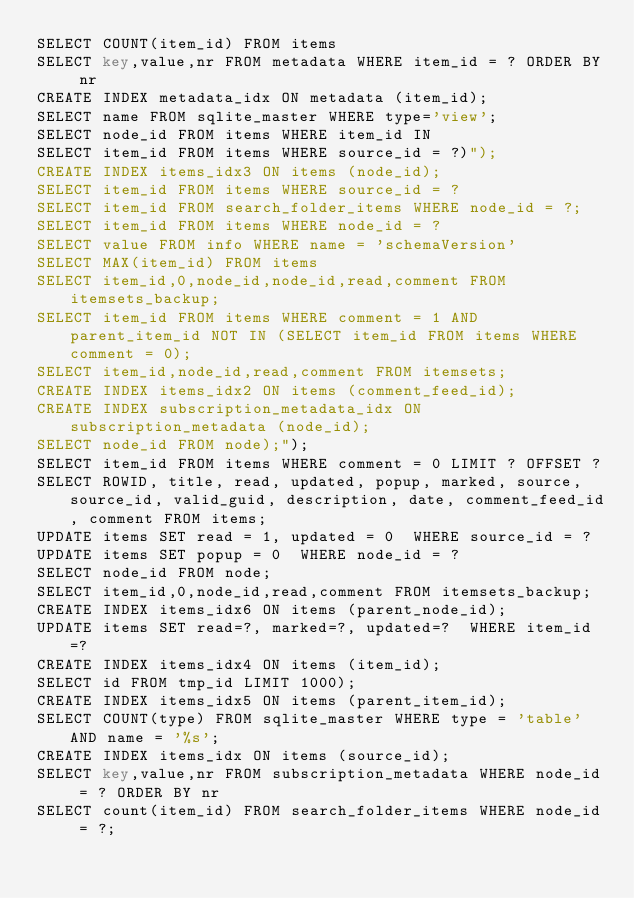Convert code to text. <code><loc_0><loc_0><loc_500><loc_500><_SQL_>SELECT COUNT(item_id) FROM items 
SELECT key,value,nr FROM metadata WHERE item_id = ? ORDER BY nr
CREATE INDEX metadata_idx ON metadata (item_id);
SELECT name FROM sqlite_master WHERE type='view';
SELECT node_id FROM items WHERE item_id IN 
SELECT item_id FROM items WHERE source_id = ?)");
CREATE INDEX items_idx3 ON items (node_id);
SELECT item_id FROM items WHERE source_id = ?
SELECT item_id FROM search_folder_items WHERE node_id = ?;
SELECT item_id FROM items WHERE node_id = ?
SELECT value FROM info WHERE name = 'schemaVersion'
SELECT MAX(item_id) FROM items
SELECT item_id,0,node_id,node_id,read,comment FROM itemsets_backup;
SELECT item_id FROM items WHERE comment = 1 AND parent_item_id NOT IN (SELECT item_id FROM items WHERE comment = 0);
SELECT item_id,node_id,read,comment FROM itemsets;
CREATE INDEX items_idx2 ON items (comment_feed_id);
CREATE INDEX subscription_metadata_idx ON subscription_metadata (node_id);
SELECT node_id FROM node);");
SELECT item_id FROM items WHERE comment = 0 LIMIT ? OFFSET ?
SELECT ROWID, title, read, updated, popup, marked, source, source_id, valid_guid, description, date, comment_feed_id, comment FROM items;
UPDATE items SET read = 1, updated = 0  WHERE source_id = ?
UPDATE items SET popup = 0  WHERE node_id = ?
SELECT node_id FROM node;
SELECT item_id,0,node_id,read,comment FROM itemsets_backup;
CREATE INDEX items_idx6 ON items (parent_node_id);
UPDATE items SET read=?, marked=?, updated=?  WHERE item_id=?
CREATE INDEX items_idx4 ON items (item_id);
SELECT id FROM tmp_id LIMIT 1000);
CREATE INDEX items_idx5 ON items (parent_item_id);
SELECT COUNT(type) FROM sqlite_master WHERE type = 'table' AND name = '%s';
CREATE INDEX items_idx ON items (source_id);
SELECT key,value,nr FROM subscription_metadata WHERE node_id = ? ORDER BY nr
SELECT count(item_id) FROM search_folder_items WHERE node_id = ?;
</code> 